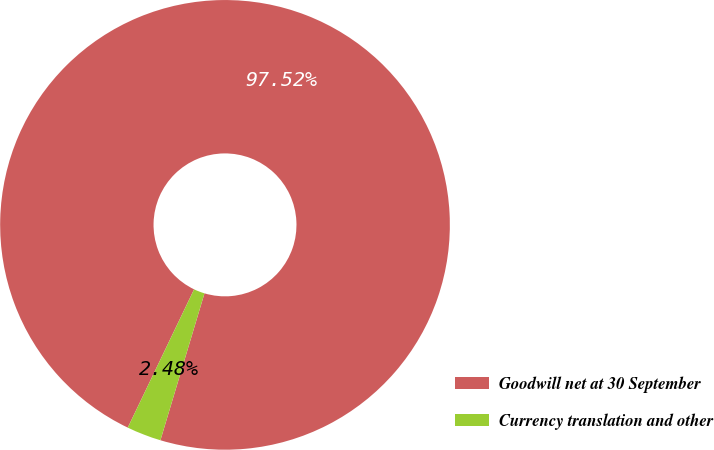Convert chart to OTSL. <chart><loc_0><loc_0><loc_500><loc_500><pie_chart><fcel>Goodwill net at 30 September<fcel>Currency translation and other<nl><fcel>97.52%<fcel>2.48%<nl></chart> 